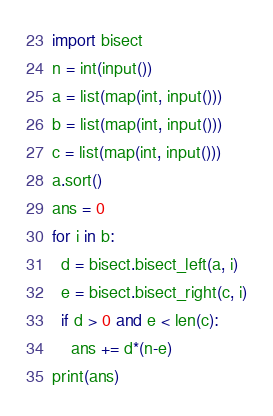Convert code to text. <code><loc_0><loc_0><loc_500><loc_500><_Python_>import bisect
n = int(input())
a = list(map(int, input()))
b = list(map(int, input()))
c = list(map(int, input()))
a.sort()
ans = 0
for i in b:
  d = bisect.bisect_left(a, i)
  e = bisect.bisect_right(c, i)
  if d > 0 and e < len(c):
    ans += d*(n-e)
print(ans)</code> 